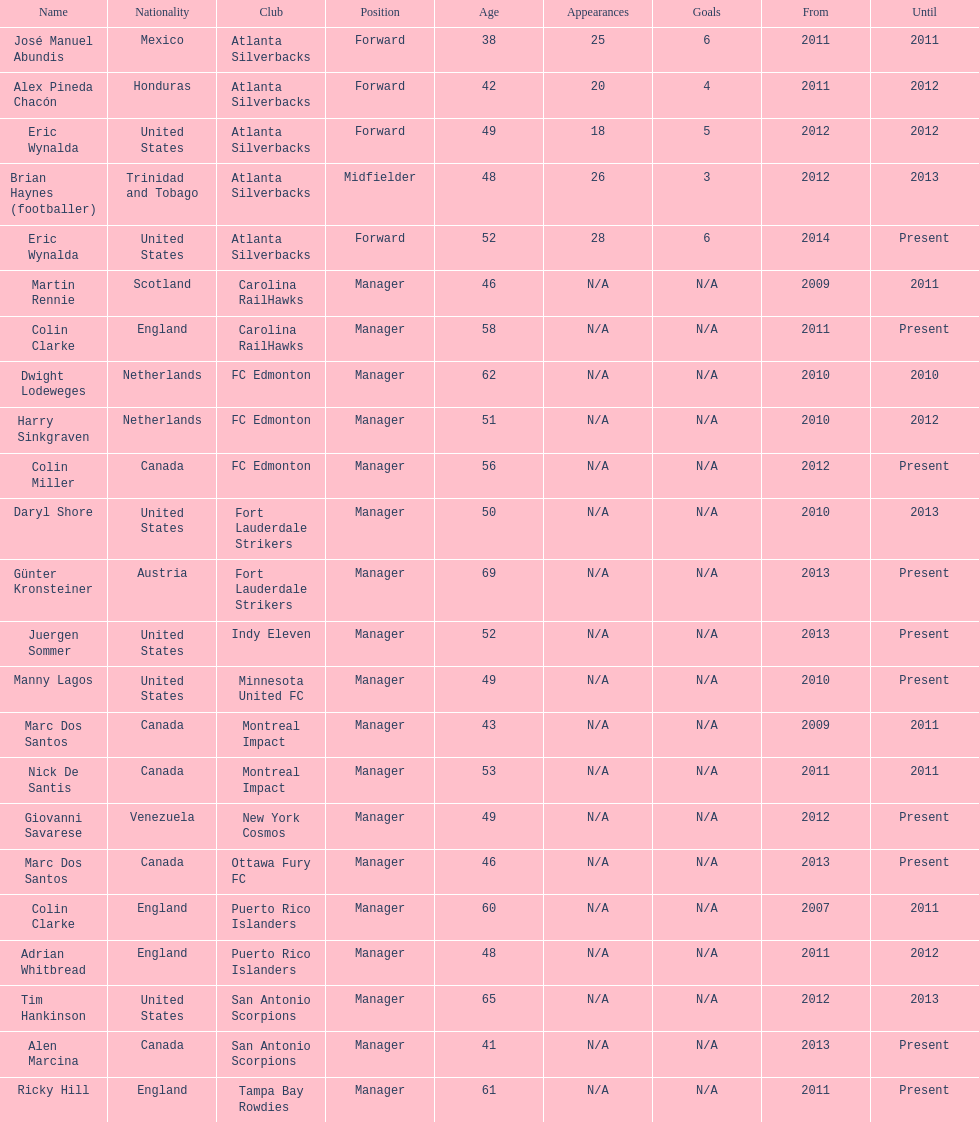Who was the coach of fc edmonton before miller? Harry Sinkgraven. 